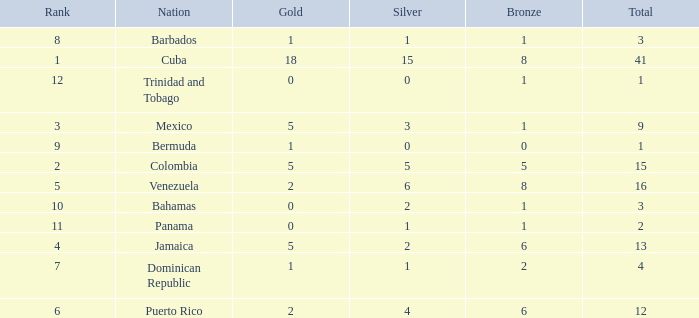Which Silver has a Gold of 2, and a Nation of puerto rico, and a Total smaller than 12? None. 